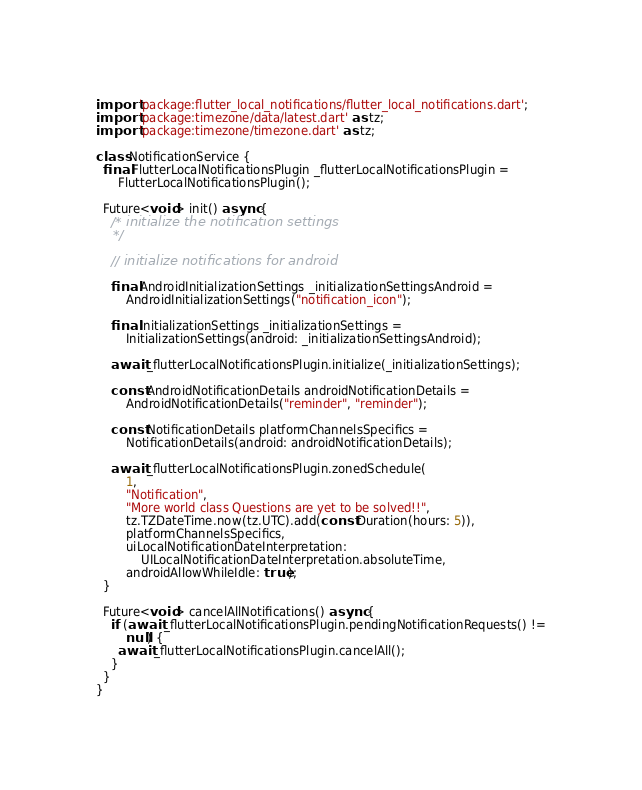Convert code to text. <code><loc_0><loc_0><loc_500><loc_500><_Dart_>import 'package:flutter_local_notifications/flutter_local_notifications.dart';
import 'package:timezone/data/latest.dart' as tz;
import 'package:timezone/timezone.dart' as tz;

class NotificationService {
  final FlutterLocalNotificationsPlugin _flutterLocalNotificationsPlugin =
      FlutterLocalNotificationsPlugin();

  Future<void> init() async {
    /* initialize the notification settings
    */

    // initialize notifications for android

    final AndroidInitializationSettings _initializationSettingsAndroid =
        AndroidInitializationSettings("notification_icon");

    final InitializationSettings _initializationSettings =
        InitializationSettings(android: _initializationSettingsAndroid);

    await _flutterLocalNotificationsPlugin.initialize(_initializationSettings);

    const AndroidNotificationDetails androidNotificationDetails =
        AndroidNotificationDetails("reminder", "reminder");

    const NotificationDetails platformChannelsSpecifics =
        NotificationDetails(android: androidNotificationDetails);

    await _flutterLocalNotificationsPlugin.zonedSchedule(
        1,
        "Notification",
        "More world class Questions are yet to be solved!!",
        tz.TZDateTime.now(tz.UTC).add(const Duration(hours: 5)),
        platformChannelsSpecifics,
        uiLocalNotificationDateInterpretation:
            UILocalNotificationDateInterpretation.absoluteTime,
        androidAllowWhileIdle: true);
  }

  Future<void> cancelAllNotifications() async {
    if (await _flutterLocalNotificationsPlugin.pendingNotificationRequests() !=
        null) {
      await _flutterLocalNotificationsPlugin.cancelAll();
    }
  }
}
</code> 